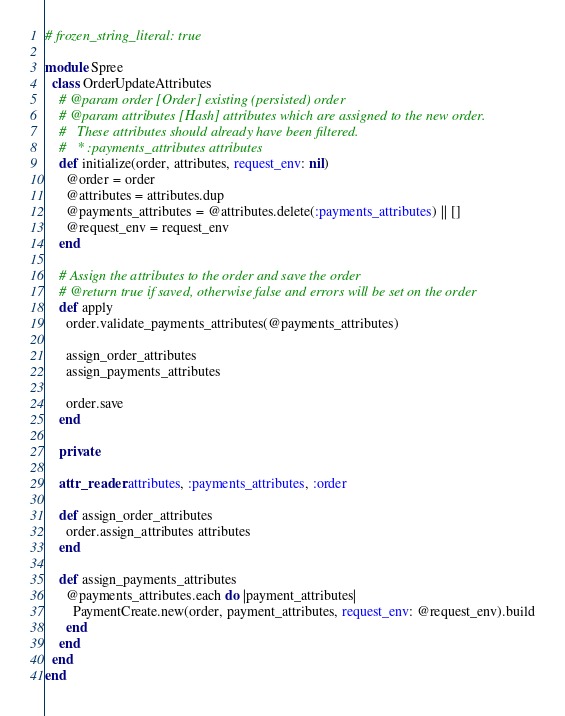Convert code to text. <code><loc_0><loc_0><loc_500><loc_500><_Ruby_># frozen_string_literal: true

module Spree
  class OrderUpdateAttributes
    # @param order [Order] existing (persisted) order
    # @param attributes [Hash] attributes which are assigned to the new order.
    #   These attributes should already have been filtered.
    #   * :payments_attributes attributes
    def initialize(order, attributes, request_env: nil)
      @order = order
      @attributes = attributes.dup
      @payments_attributes = @attributes.delete(:payments_attributes) || []
      @request_env = request_env
    end

    # Assign the attributes to the order and save the order
    # @return true if saved, otherwise false and errors will be set on the order
    def apply
      order.validate_payments_attributes(@payments_attributes)

      assign_order_attributes
      assign_payments_attributes

      order.save
    end

    private

    attr_reader :attributes, :payments_attributes, :order

    def assign_order_attributes
      order.assign_attributes attributes
    end

    def assign_payments_attributes
      @payments_attributes.each do |payment_attributes|
        PaymentCreate.new(order, payment_attributes, request_env: @request_env).build
      end
    end
  end
end
</code> 